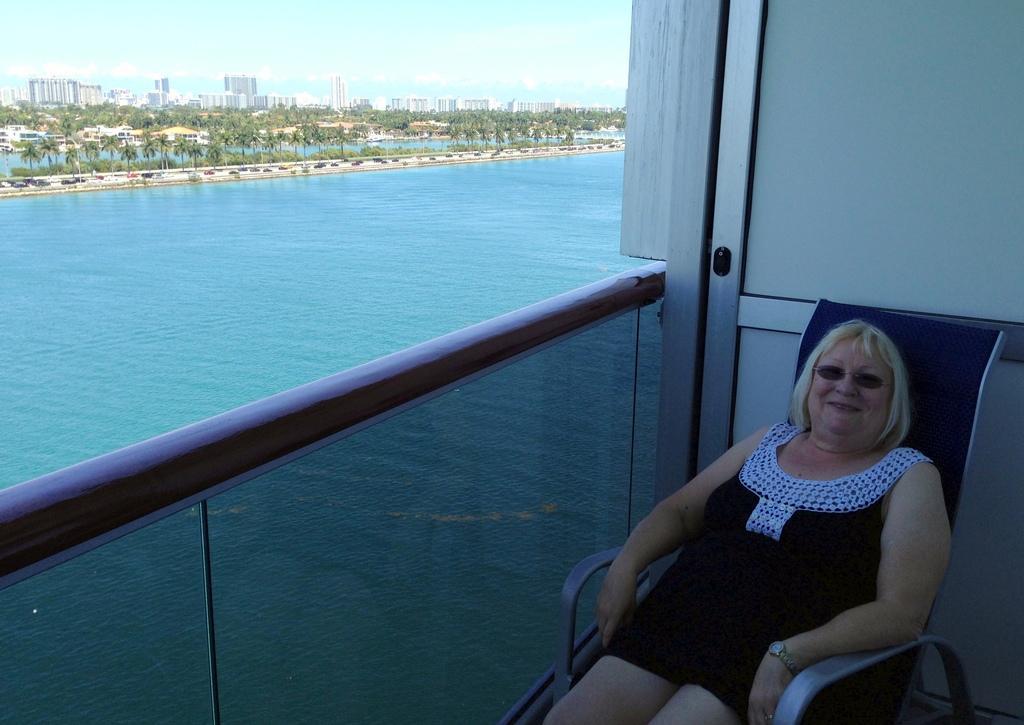Could you give a brief overview of what you see in this image? On the right side of the image a lady is sitting on the chair. In the middle of the image water is there. At the top of the image we can see buildings, trees are present. At the top of the image sky is there. 